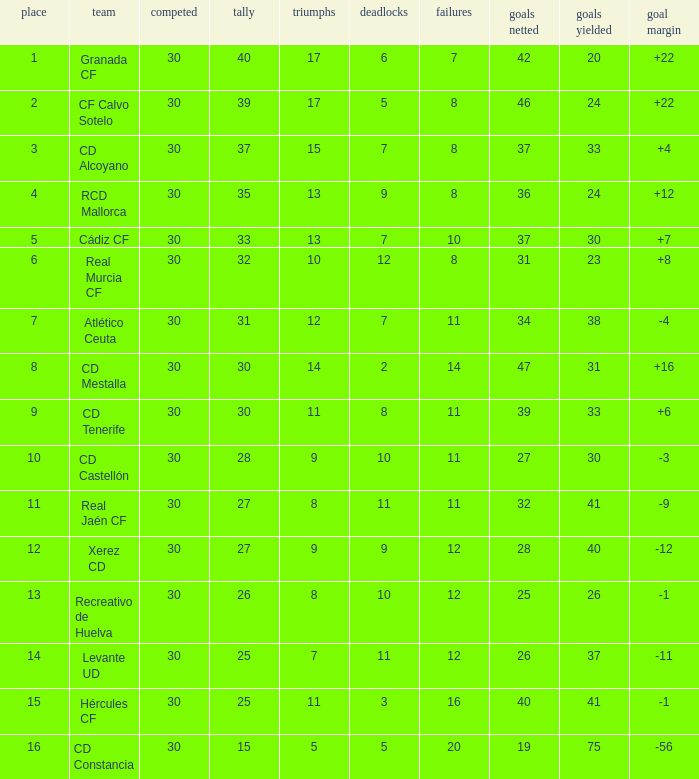How many Wins have Goals against smaller than 30, and Goals for larger than 25, and Draws larger than 5? 3.0. 